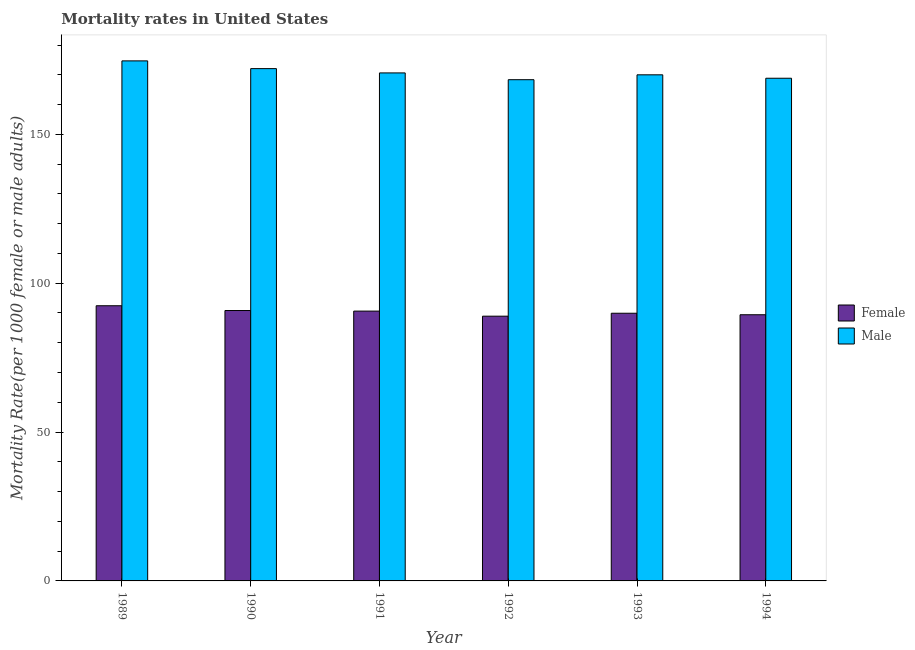How many different coloured bars are there?
Provide a short and direct response. 2. How many groups of bars are there?
Ensure brevity in your answer.  6. Are the number of bars per tick equal to the number of legend labels?
Keep it short and to the point. Yes. Are the number of bars on each tick of the X-axis equal?
Keep it short and to the point. Yes. In how many cases, is the number of bars for a given year not equal to the number of legend labels?
Your answer should be very brief. 0. What is the female mortality rate in 1991?
Ensure brevity in your answer.  90.63. Across all years, what is the maximum male mortality rate?
Provide a short and direct response. 174.68. Across all years, what is the minimum male mortality rate?
Your answer should be very brief. 168.36. In which year was the female mortality rate maximum?
Your answer should be compact. 1989. In which year was the female mortality rate minimum?
Keep it short and to the point. 1992. What is the total female mortality rate in the graph?
Provide a succinct answer. 542.13. What is the difference between the female mortality rate in 1989 and that in 1992?
Provide a succinct answer. 3.5. What is the difference between the female mortality rate in 1990 and the male mortality rate in 1989?
Your answer should be compact. -1.61. What is the average male mortality rate per year?
Your answer should be very brief. 170.77. What is the ratio of the male mortality rate in 1992 to that in 1993?
Your response must be concise. 0.99. Is the female mortality rate in 1989 less than that in 1993?
Provide a succinct answer. No. Is the difference between the male mortality rate in 1991 and 1992 greater than the difference between the female mortality rate in 1991 and 1992?
Provide a short and direct response. No. What is the difference between the highest and the second highest male mortality rate?
Make the answer very short. 2.6. What is the difference between the highest and the lowest female mortality rate?
Your answer should be very brief. 3.5. What does the 2nd bar from the left in 1989 represents?
Offer a terse response. Male. What does the 1st bar from the right in 1990 represents?
Your answer should be very brief. Male. How many bars are there?
Your response must be concise. 12. Are all the bars in the graph horizontal?
Offer a very short reply. No. How many years are there in the graph?
Your response must be concise. 6. Does the graph contain any zero values?
Offer a terse response. No. Does the graph contain grids?
Keep it short and to the point. No. Where does the legend appear in the graph?
Ensure brevity in your answer.  Center right. How many legend labels are there?
Your response must be concise. 2. What is the title of the graph?
Your answer should be very brief. Mortality rates in United States. Does "Private credit bureau" appear as one of the legend labels in the graph?
Your answer should be compact. No. What is the label or title of the Y-axis?
Ensure brevity in your answer.  Mortality Rate(per 1000 female or male adults). What is the Mortality Rate(per 1000 female or male adults) of Female in 1989?
Offer a terse response. 92.43. What is the Mortality Rate(per 1000 female or male adults) in Male in 1989?
Your response must be concise. 174.68. What is the Mortality Rate(per 1000 female or male adults) of Female in 1990?
Keep it short and to the point. 90.82. What is the Mortality Rate(per 1000 female or male adults) in Male in 1990?
Offer a terse response. 172.08. What is the Mortality Rate(per 1000 female or male adults) of Female in 1991?
Offer a terse response. 90.63. What is the Mortality Rate(per 1000 female or male adults) of Male in 1991?
Keep it short and to the point. 170.64. What is the Mortality Rate(per 1000 female or male adults) in Female in 1992?
Give a very brief answer. 88.93. What is the Mortality Rate(per 1000 female or male adults) of Male in 1992?
Keep it short and to the point. 168.36. What is the Mortality Rate(per 1000 female or male adults) of Female in 1993?
Give a very brief answer. 89.91. What is the Mortality Rate(per 1000 female or male adults) of Male in 1993?
Ensure brevity in your answer.  170. What is the Mortality Rate(per 1000 female or male adults) in Female in 1994?
Ensure brevity in your answer.  89.41. What is the Mortality Rate(per 1000 female or male adults) in Male in 1994?
Your answer should be compact. 168.85. Across all years, what is the maximum Mortality Rate(per 1000 female or male adults) of Female?
Ensure brevity in your answer.  92.43. Across all years, what is the maximum Mortality Rate(per 1000 female or male adults) in Male?
Offer a terse response. 174.68. Across all years, what is the minimum Mortality Rate(per 1000 female or male adults) in Female?
Provide a succinct answer. 88.93. Across all years, what is the minimum Mortality Rate(per 1000 female or male adults) in Male?
Your answer should be very brief. 168.36. What is the total Mortality Rate(per 1000 female or male adults) in Female in the graph?
Give a very brief answer. 542.13. What is the total Mortality Rate(per 1000 female or male adults) in Male in the graph?
Make the answer very short. 1024.6. What is the difference between the Mortality Rate(per 1000 female or male adults) in Female in 1989 and that in 1990?
Offer a terse response. 1.61. What is the difference between the Mortality Rate(per 1000 female or male adults) in Male in 1989 and that in 1990?
Ensure brevity in your answer.  2.6. What is the difference between the Mortality Rate(per 1000 female or male adults) of Male in 1989 and that in 1991?
Offer a terse response. 4.04. What is the difference between the Mortality Rate(per 1000 female or male adults) of Female in 1989 and that in 1992?
Provide a succinct answer. 3.5. What is the difference between the Mortality Rate(per 1000 female or male adults) of Male in 1989 and that in 1992?
Provide a short and direct response. 6.32. What is the difference between the Mortality Rate(per 1000 female or male adults) of Female in 1989 and that in 1993?
Make the answer very short. 2.52. What is the difference between the Mortality Rate(per 1000 female or male adults) of Male in 1989 and that in 1993?
Your answer should be very brief. 4.68. What is the difference between the Mortality Rate(per 1000 female or male adults) of Female in 1989 and that in 1994?
Your response must be concise. 3.02. What is the difference between the Mortality Rate(per 1000 female or male adults) of Male in 1989 and that in 1994?
Your answer should be very brief. 5.83. What is the difference between the Mortality Rate(per 1000 female or male adults) in Female in 1990 and that in 1991?
Ensure brevity in your answer.  0.19. What is the difference between the Mortality Rate(per 1000 female or male adults) in Male in 1990 and that in 1991?
Give a very brief answer. 1.44. What is the difference between the Mortality Rate(per 1000 female or male adults) of Female in 1990 and that in 1992?
Offer a very short reply. 1.9. What is the difference between the Mortality Rate(per 1000 female or male adults) of Male in 1990 and that in 1992?
Offer a terse response. 3.72. What is the difference between the Mortality Rate(per 1000 female or male adults) in Female in 1990 and that in 1993?
Offer a very short reply. 0.91. What is the difference between the Mortality Rate(per 1000 female or male adults) of Male in 1990 and that in 1993?
Provide a succinct answer. 2.08. What is the difference between the Mortality Rate(per 1000 female or male adults) in Female in 1990 and that in 1994?
Ensure brevity in your answer.  1.41. What is the difference between the Mortality Rate(per 1000 female or male adults) in Male in 1990 and that in 1994?
Your answer should be compact. 3.23. What is the difference between the Mortality Rate(per 1000 female or male adults) in Female in 1991 and that in 1992?
Ensure brevity in your answer.  1.7. What is the difference between the Mortality Rate(per 1000 female or male adults) of Male in 1991 and that in 1992?
Ensure brevity in your answer.  2.28. What is the difference between the Mortality Rate(per 1000 female or male adults) of Female in 1991 and that in 1993?
Your answer should be very brief. 0.72. What is the difference between the Mortality Rate(per 1000 female or male adults) of Male in 1991 and that in 1993?
Your response must be concise. 0.64. What is the difference between the Mortality Rate(per 1000 female or male adults) of Female in 1991 and that in 1994?
Keep it short and to the point. 1.22. What is the difference between the Mortality Rate(per 1000 female or male adults) of Male in 1991 and that in 1994?
Provide a succinct answer. 1.79. What is the difference between the Mortality Rate(per 1000 female or male adults) of Female in 1992 and that in 1993?
Your answer should be compact. -0.98. What is the difference between the Mortality Rate(per 1000 female or male adults) of Male in 1992 and that in 1993?
Give a very brief answer. -1.64. What is the difference between the Mortality Rate(per 1000 female or male adults) in Female in 1992 and that in 1994?
Your answer should be compact. -0.48. What is the difference between the Mortality Rate(per 1000 female or male adults) of Male in 1992 and that in 1994?
Your answer should be compact. -0.49. What is the difference between the Mortality Rate(per 1000 female or male adults) in Female in 1993 and that in 1994?
Give a very brief answer. 0.5. What is the difference between the Mortality Rate(per 1000 female or male adults) of Male in 1993 and that in 1994?
Make the answer very short. 1.15. What is the difference between the Mortality Rate(per 1000 female or male adults) of Female in 1989 and the Mortality Rate(per 1000 female or male adults) of Male in 1990?
Your answer should be very brief. -79.65. What is the difference between the Mortality Rate(per 1000 female or male adults) in Female in 1989 and the Mortality Rate(per 1000 female or male adults) in Male in 1991?
Your answer should be compact. -78.21. What is the difference between the Mortality Rate(per 1000 female or male adults) in Female in 1989 and the Mortality Rate(per 1000 female or male adults) in Male in 1992?
Provide a short and direct response. -75.93. What is the difference between the Mortality Rate(per 1000 female or male adults) of Female in 1989 and the Mortality Rate(per 1000 female or male adults) of Male in 1993?
Provide a succinct answer. -77.57. What is the difference between the Mortality Rate(per 1000 female or male adults) of Female in 1989 and the Mortality Rate(per 1000 female or male adults) of Male in 1994?
Give a very brief answer. -76.42. What is the difference between the Mortality Rate(per 1000 female or male adults) of Female in 1990 and the Mortality Rate(per 1000 female or male adults) of Male in 1991?
Give a very brief answer. -79.81. What is the difference between the Mortality Rate(per 1000 female or male adults) of Female in 1990 and the Mortality Rate(per 1000 female or male adults) of Male in 1992?
Keep it short and to the point. -77.53. What is the difference between the Mortality Rate(per 1000 female or male adults) in Female in 1990 and the Mortality Rate(per 1000 female or male adults) in Male in 1993?
Your answer should be compact. -79.17. What is the difference between the Mortality Rate(per 1000 female or male adults) of Female in 1990 and the Mortality Rate(per 1000 female or male adults) of Male in 1994?
Your answer should be very brief. -78.02. What is the difference between the Mortality Rate(per 1000 female or male adults) in Female in 1991 and the Mortality Rate(per 1000 female or male adults) in Male in 1992?
Offer a very short reply. -77.73. What is the difference between the Mortality Rate(per 1000 female or male adults) of Female in 1991 and the Mortality Rate(per 1000 female or male adults) of Male in 1993?
Provide a short and direct response. -79.37. What is the difference between the Mortality Rate(per 1000 female or male adults) in Female in 1991 and the Mortality Rate(per 1000 female or male adults) in Male in 1994?
Offer a very short reply. -78.22. What is the difference between the Mortality Rate(per 1000 female or male adults) of Female in 1992 and the Mortality Rate(per 1000 female or male adults) of Male in 1993?
Your answer should be compact. -81.07. What is the difference between the Mortality Rate(per 1000 female or male adults) of Female in 1992 and the Mortality Rate(per 1000 female or male adults) of Male in 1994?
Offer a terse response. -79.92. What is the difference between the Mortality Rate(per 1000 female or male adults) in Female in 1993 and the Mortality Rate(per 1000 female or male adults) in Male in 1994?
Give a very brief answer. -78.94. What is the average Mortality Rate(per 1000 female or male adults) of Female per year?
Your answer should be compact. 90.36. What is the average Mortality Rate(per 1000 female or male adults) of Male per year?
Your answer should be compact. 170.77. In the year 1989, what is the difference between the Mortality Rate(per 1000 female or male adults) in Female and Mortality Rate(per 1000 female or male adults) in Male?
Offer a terse response. -82.25. In the year 1990, what is the difference between the Mortality Rate(per 1000 female or male adults) of Female and Mortality Rate(per 1000 female or male adults) of Male?
Keep it short and to the point. -81.25. In the year 1991, what is the difference between the Mortality Rate(per 1000 female or male adults) in Female and Mortality Rate(per 1000 female or male adults) in Male?
Your response must be concise. -80.01. In the year 1992, what is the difference between the Mortality Rate(per 1000 female or male adults) of Female and Mortality Rate(per 1000 female or male adults) of Male?
Offer a very short reply. -79.43. In the year 1993, what is the difference between the Mortality Rate(per 1000 female or male adults) of Female and Mortality Rate(per 1000 female or male adults) of Male?
Provide a short and direct response. -80.09. In the year 1994, what is the difference between the Mortality Rate(per 1000 female or male adults) of Female and Mortality Rate(per 1000 female or male adults) of Male?
Offer a very short reply. -79.44. What is the ratio of the Mortality Rate(per 1000 female or male adults) of Female in 1989 to that in 1990?
Give a very brief answer. 1.02. What is the ratio of the Mortality Rate(per 1000 female or male adults) in Male in 1989 to that in 1990?
Keep it short and to the point. 1.02. What is the ratio of the Mortality Rate(per 1000 female or male adults) of Female in 1989 to that in 1991?
Provide a succinct answer. 1.02. What is the ratio of the Mortality Rate(per 1000 female or male adults) of Male in 1989 to that in 1991?
Your answer should be compact. 1.02. What is the ratio of the Mortality Rate(per 1000 female or male adults) of Female in 1989 to that in 1992?
Offer a terse response. 1.04. What is the ratio of the Mortality Rate(per 1000 female or male adults) of Male in 1989 to that in 1992?
Provide a succinct answer. 1.04. What is the ratio of the Mortality Rate(per 1000 female or male adults) in Female in 1989 to that in 1993?
Keep it short and to the point. 1.03. What is the ratio of the Mortality Rate(per 1000 female or male adults) of Male in 1989 to that in 1993?
Your response must be concise. 1.03. What is the ratio of the Mortality Rate(per 1000 female or male adults) of Female in 1989 to that in 1994?
Keep it short and to the point. 1.03. What is the ratio of the Mortality Rate(per 1000 female or male adults) of Male in 1989 to that in 1994?
Ensure brevity in your answer.  1.03. What is the ratio of the Mortality Rate(per 1000 female or male adults) in Male in 1990 to that in 1991?
Ensure brevity in your answer.  1.01. What is the ratio of the Mortality Rate(per 1000 female or male adults) of Female in 1990 to that in 1992?
Offer a very short reply. 1.02. What is the ratio of the Mortality Rate(per 1000 female or male adults) in Male in 1990 to that in 1992?
Your answer should be compact. 1.02. What is the ratio of the Mortality Rate(per 1000 female or male adults) in Female in 1990 to that in 1993?
Ensure brevity in your answer.  1.01. What is the ratio of the Mortality Rate(per 1000 female or male adults) of Male in 1990 to that in 1993?
Make the answer very short. 1.01. What is the ratio of the Mortality Rate(per 1000 female or male adults) of Female in 1990 to that in 1994?
Provide a short and direct response. 1.02. What is the ratio of the Mortality Rate(per 1000 female or male adults) of Male in 1990 to that in 1994?
Your answer should be compact. 1.02. What is the ratio of the Mortality Rate(per 1000 female or male adults) in Female in 1991 to that in 1992?
Offer a terse response. 1.02. What is the ratio of the Mortality Rate(per 1000 female or male adults) in Male in 1991 to that in 1992?
Your answer should be compact. 1.01. What is the ratio of the Mortality Rate(per 1000 female or male adults) in Female in 1991 to that in 1993?
Offer a very short reply. 1.01. What is the ratio of the Mortality Rate(per 1000 female or male adults) in Male in 1991 to that in 1993?
Your answer should be very brief. 1. What is the ratio of the Mortality Rate(per 1000 female or male adults) of Female in 1991 to that in 1994?
Offer a terse response. 1.01. What is the ratio of the Mortality Rate(per 1000 female or male adults) in Male in 1991 to that in 1994?
Provide a succinct answer. 1.01. What is the ratio of the Mortality Rate(per 1000 female or male adults) of Male in 1992 to that in 1993?
Your response must be concise. 0.99. What is the ratio of the Mortality Rate(per 1000 female or male adults) of Female in 1993 to that in 1994?
Make the answer very short. 1.01. What is the ratio of the Mortality Rate(per 1000 female or male adults) of Male in 1993 to that in 1994?
Offer a very short reply. 1.01. What is the difference between the highest and the second highest Mortality Rate(per 1000 female or male adults) of Female?
Give a very brief answer. 1.61. What is the difference between the highest and the second highest Mortality Rate(per 1000 female or male adults) in Male?
Ensure brevity in your answer.  2.6. What is the difference between the highest and the lowest Mortality Rate(per 1000 female or male adults) of Female?
Offer a terse response. 3.5. What is the difference between the highest and the lowest Mortality Rate(per 1000 female or male adults) in Male?
Your answer should be very brief. 6.32. 